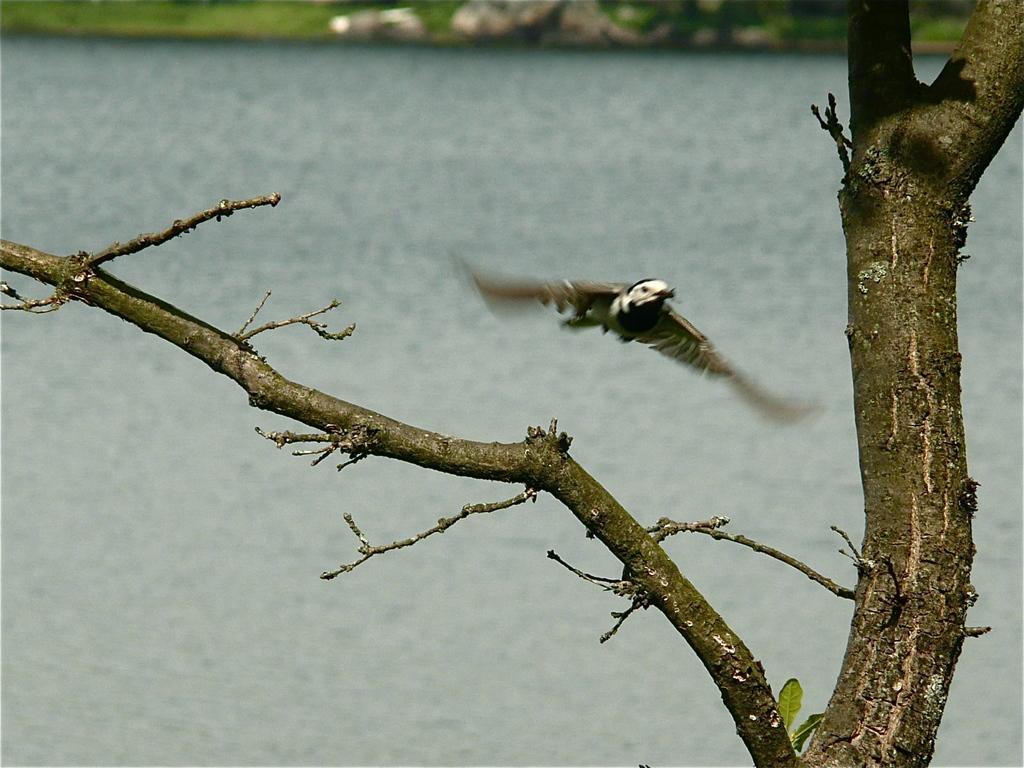Can you describe this image briefly? In this picture I can see a bird in the air and also I can see tree. 